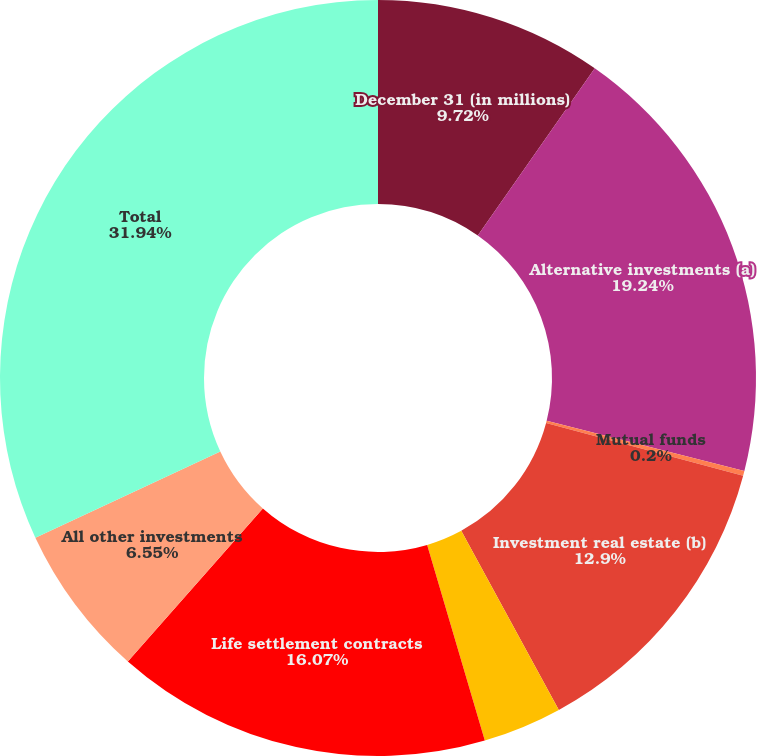Convert chart. <chart><loc_0><loc_0><loc_500><loc_500><pie_chart><fcel>December 31 (in millions)<fcel>Alternative investments (a)<fcel>Mutual funds<fcel>Investment real estate (b)<fcel>Aircraft asset investments (c)<fcel>Life settlement contracts<fcel>All other investments<fcel>Total<nl><fcel>9.72%<fcel>19.24%<fcel>0.2%<fcel>12.9%<fcel>3.38%<fcel>16.07%<fcel>6.55%<fcel>31.94%<nl></chart> 